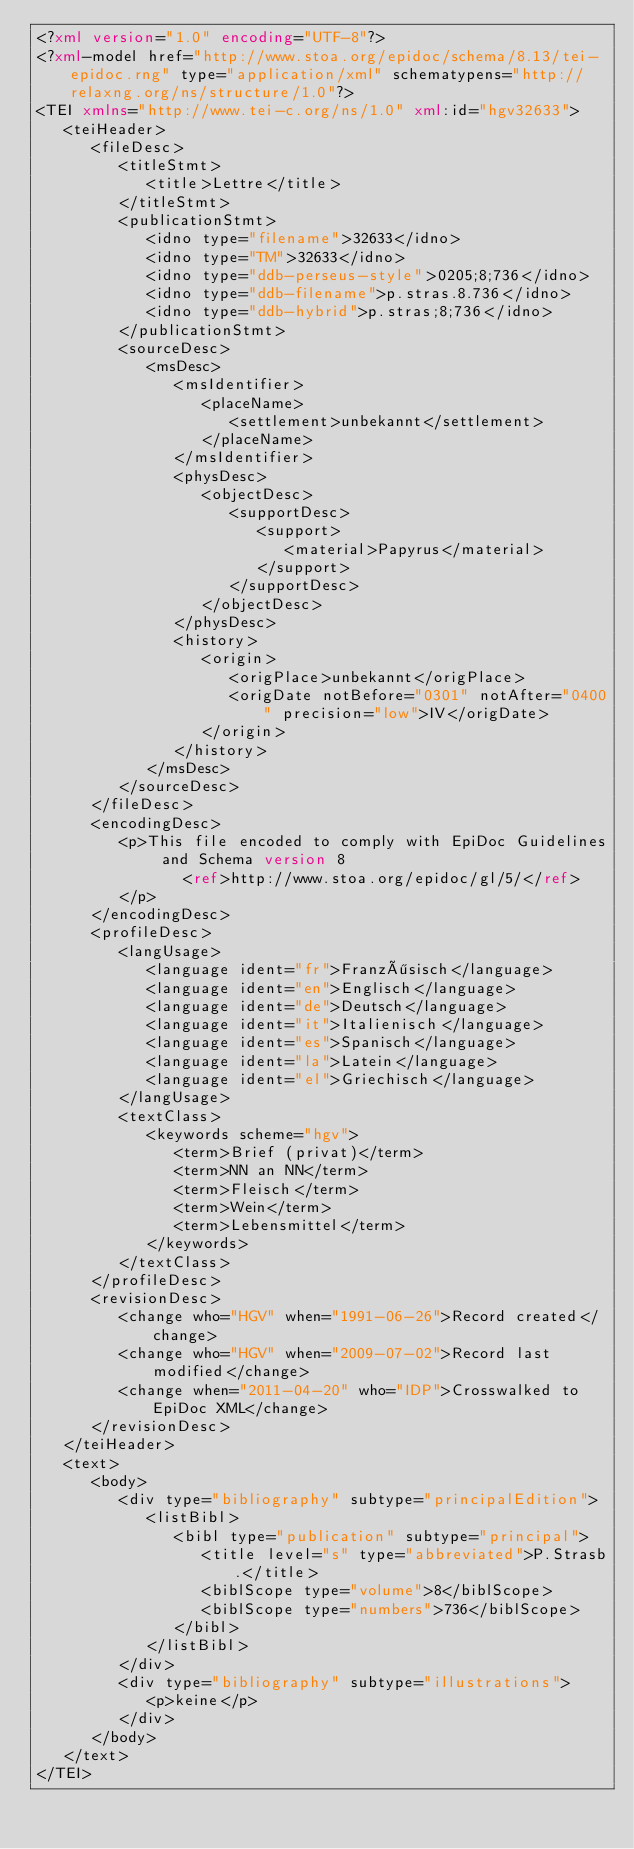<code> <loc_0><loc_0><loc_500><loc_500><_XML_><?xml version="1.0" encoding="UTF-8"?>
<?xml-model href="http://www.stoa.org/epidoc/schema/8.13/tei-epidoc.rng" type="application/xml" schematypens="http://relaxng.org/ns/structure/1.0"?>
<TEI xmlns="http://www.tei-c.org/ns/1.0" xml:id="hgv32633">
   <teiHeader>
      <fileDesc>
         <titleStmt>
            <title>Lettre</title>
         </titleStmt>
         <publicationStmt>
            <idno type="filename">32633</idno>
            <idno type="TM">32633</idno>
            <idno type="ddb-perseus-style">0205;8;736</idno>
            <idno type="ddb-filename">p.stras.8.736</idno>
            <idno type="ddb-hybrid">p.stras;8;736</idno>
         </publicationStmt>
         <sourceDesc>
            <msDesc>
               <msIdentifier>
                  <placeName>
                     <settlement>unbekannt</settlement>
                  </placeName>
               </msIdentifier>
               <physDesc>
                  <objectDesc>
                     <supportDesc>
                        <support>
                           <material>Papyrus</material>
                        </support>
                     </supportDesc>
                  </objectDesc>
               </physDesc>
               <history>
                  <origin>
                     <origPlace>unbekannt</origPlace>
                     <origDate notBefore="0301" notAfter="0400" precision="low">IV</origDate>
                  </origin>
               </history>
            </msDesc>
         </sourceDesc>
      </fileDesc>
      <encodingDesc>
         <p>This file encoded to comply with EpiDoc Guidelines and Schema version 8
                <ref>http://www.stoa.org/epidoc/gl/5/</ref>
         </p>
      </encodingDesc>
      <profileDesc>
         <langUsage>
            <language ident="fr">Französisch</language>
            <language ident="en">Englisch</language>
            <language ident="de">Deutsch</language>
            <language ident="it">Italienisch</language>
            <language ident="es">Spanisch</language>
            <language ident="la">Latein</language>
            <language ident="el">Griechisch</language>
         </langUsage>
         <textClass>
            <keywords scheme="hgv">
               <term>Brief (privat)</term>
               <term>NN an NN</term>
               <term>Fleisch</term>
               <term>Wein</term>
               <term>Lebensmittel</term>
            </keywords>
         </textClass>
      </profileDesc>
      <revisionDesc>
         <change who="HGV" when="1991-06-26">Record created</change>
         <change who="HGV" when="2009-07-02">Record last modified</change>
         <change when="2011-04-20" who="IDP">Crosswalked to EpiDoc XML</change>
      </revisionDesc>
   </teiHeader>
   <text>
      <body>
         <div type="bibliography" subtype="principalEdition">
            <listBibl>
               <bibl type="publication" subtype="principal">
                  <title level="s" type="abbreviated">P.Strasb.</title>
                  <biblScope type="volume">8</biblScope>
                  <biblScope type="numbers">736</biblScope>
               </bibl>
            </listBibl>
         </div>
         <div type="bibliography" subtype="illustrations">
            <p>keine</p>
         </div>
      </body>
   </text>
</TEI>
</code> 